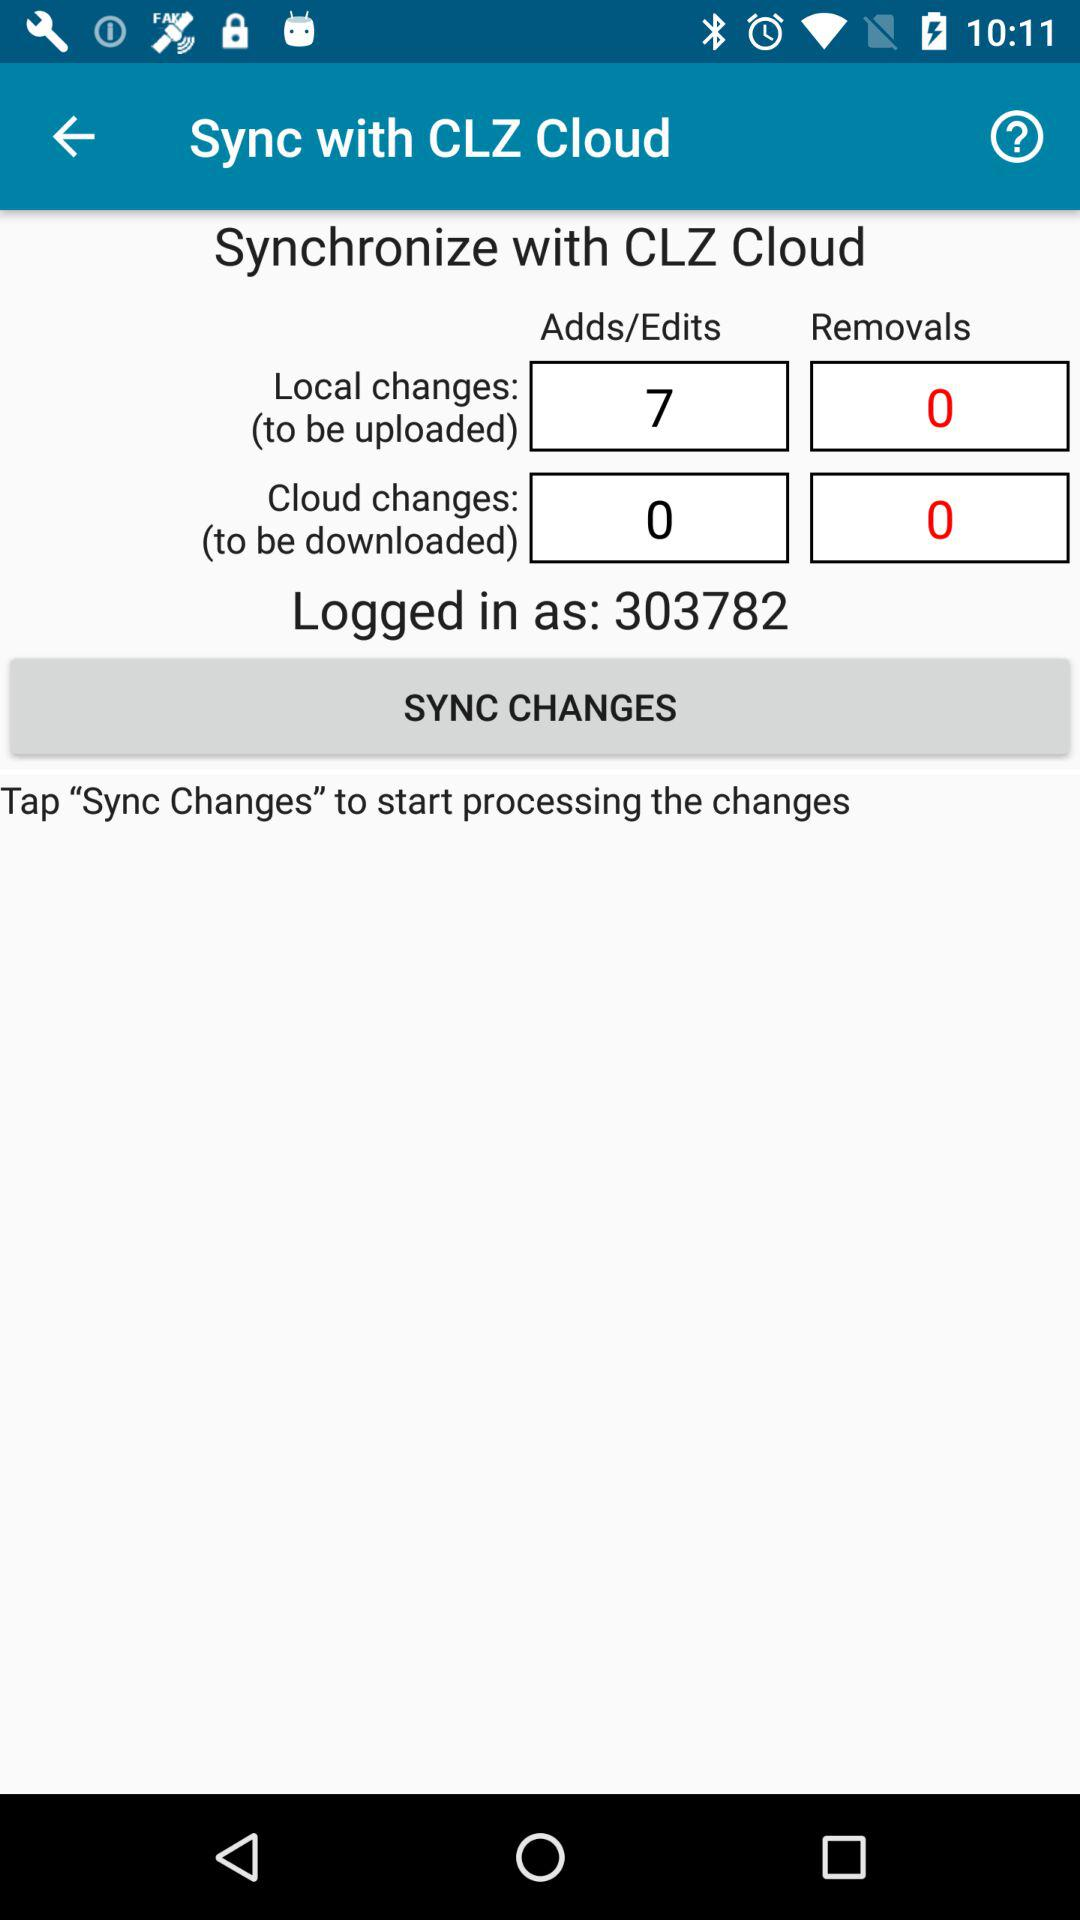What kind of data might be represented by the additions and removals shown in the sync? The additions and removals typically represent updates to a user's database or collection. Additions are new entries or modifications to existing ones, while removals indicate items that have been deleted. This could be anything from book titles, music albums, to entries in a product inventory. 